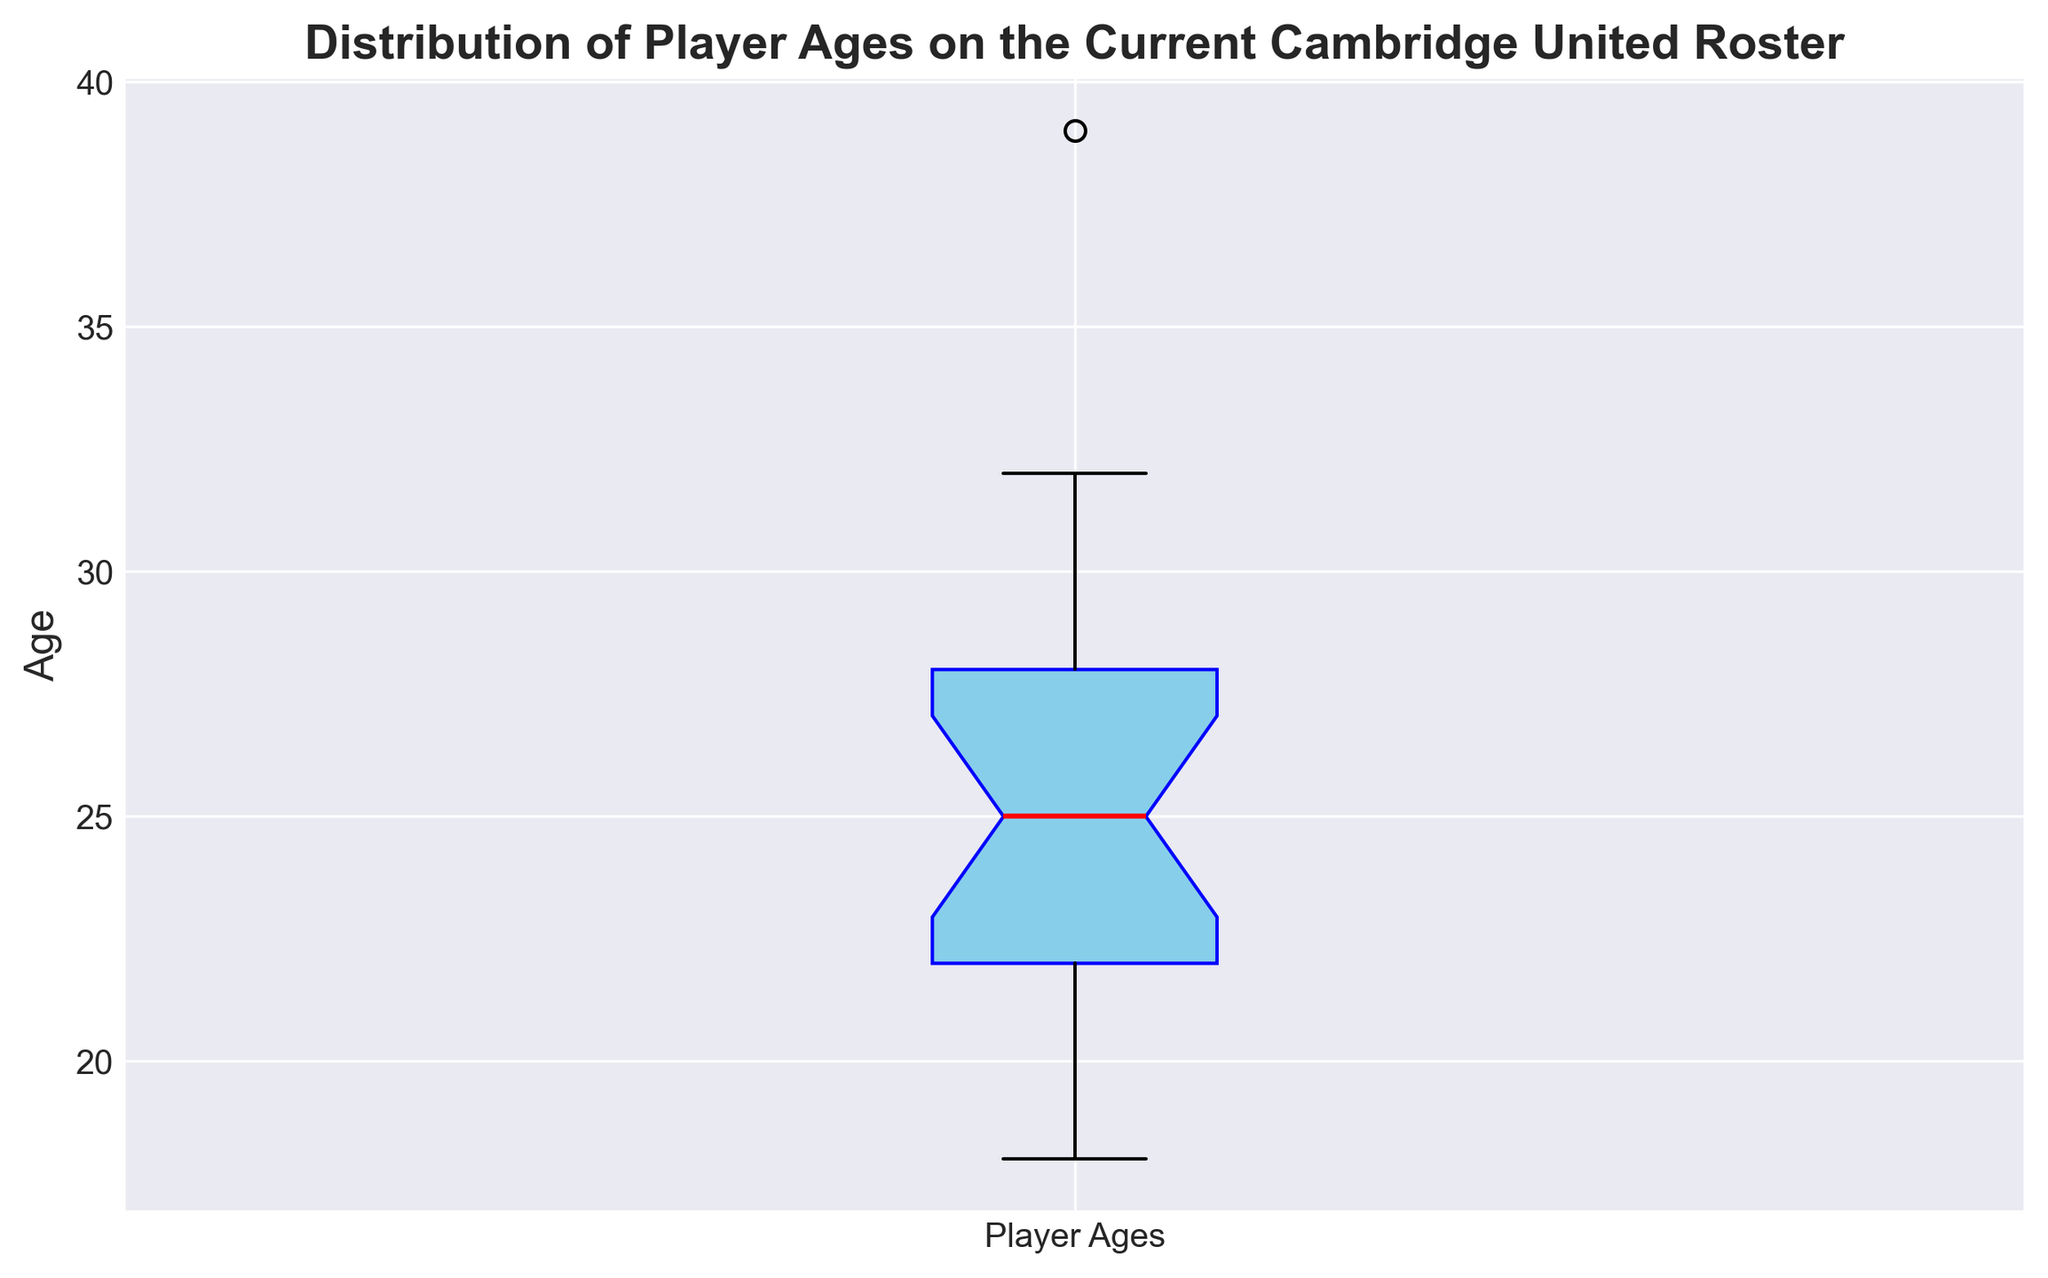What is the median age of the players? Since it's a box plot, the median age is represented by the red horizontal line inside the box. The median age of the players is given by the value of this line.
Answer: 25 What is the range of player ages on the Cambridge United roster? The range of the player ages is the difference between the maximum and minimum values, which are shown by the top and bottom whiskers of the box plot.
Answer: 39 - 18 = 21 Which player age represents the upper quartile in the distribution? The upper quartile (Q3) is represented by the top edge of the box. This value indicates the 75th percentile of the data.
Answer: 29 Are there any outliers in the distribution of player ages? Outliers in a box plot are typically represented by individual points outside the whiskers. From the box plot, if no single data points are isolated outside the whiskers, it means there are no outliers.
Answer: No How does the age of the oldest player compare to the interquartile range (IQR)? The Interquartile Range (IQR) is the difference between Q1 and Q3. The oldest player's age is the maximum value represented by the upper whisker. Comparing it involves checking how far the top whisker extends beyond Q3 and if it covers a significant portion relative to the IQR's length.
Answer: The oldest player is 39, more than a full IQR (6 years) above Q3 (29) What is the average age of the players within the interquartile range (IQR)? The IQR includes ages between Q1 (21) and Q3 (29). The ages within this range are 22, 23, 24, 25, 26, 27, and 28. Sum these values and divide by the number of players. (22+23+24+25+26+27+28) / 7 = 25
Answer: 25 What does the height of the box in the box plot indicate about the distribution of player ages? The height of the box corresponds to the IQR, which indicates how spread out the middle 50% of the ages are. Taller boxes indicate more variability within this range.
Answer: It indicates a moderate spread of ages in the middle 50% Do more players fall above or below the median age? The box plot shows the median with a red line. We compare the number of ages above and below this line. From the median line, there would be an equal number above and below if the distribution is symmetric.
Answer: Equal number above and below What age marks the 25th percentile in the player distribution? The 25th percentile, or Q1, is indicated by the bottom edge of the box. This value represents the age below which 25% of the players fall.
Answer: 21 